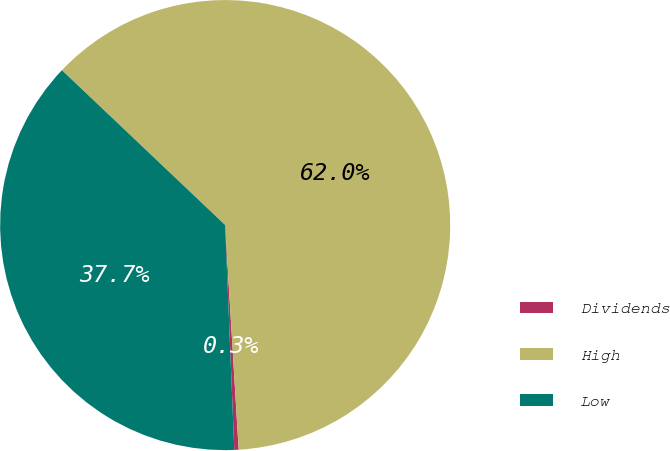<chart> <loc_0><loc_0><loc_500><loc_500><pie_chart><fcel>Dividends<fcel>High<fcel>Low<nl><fcel>0.31%<fcel>61.97%<fcel>37.73%<nl></chart> 